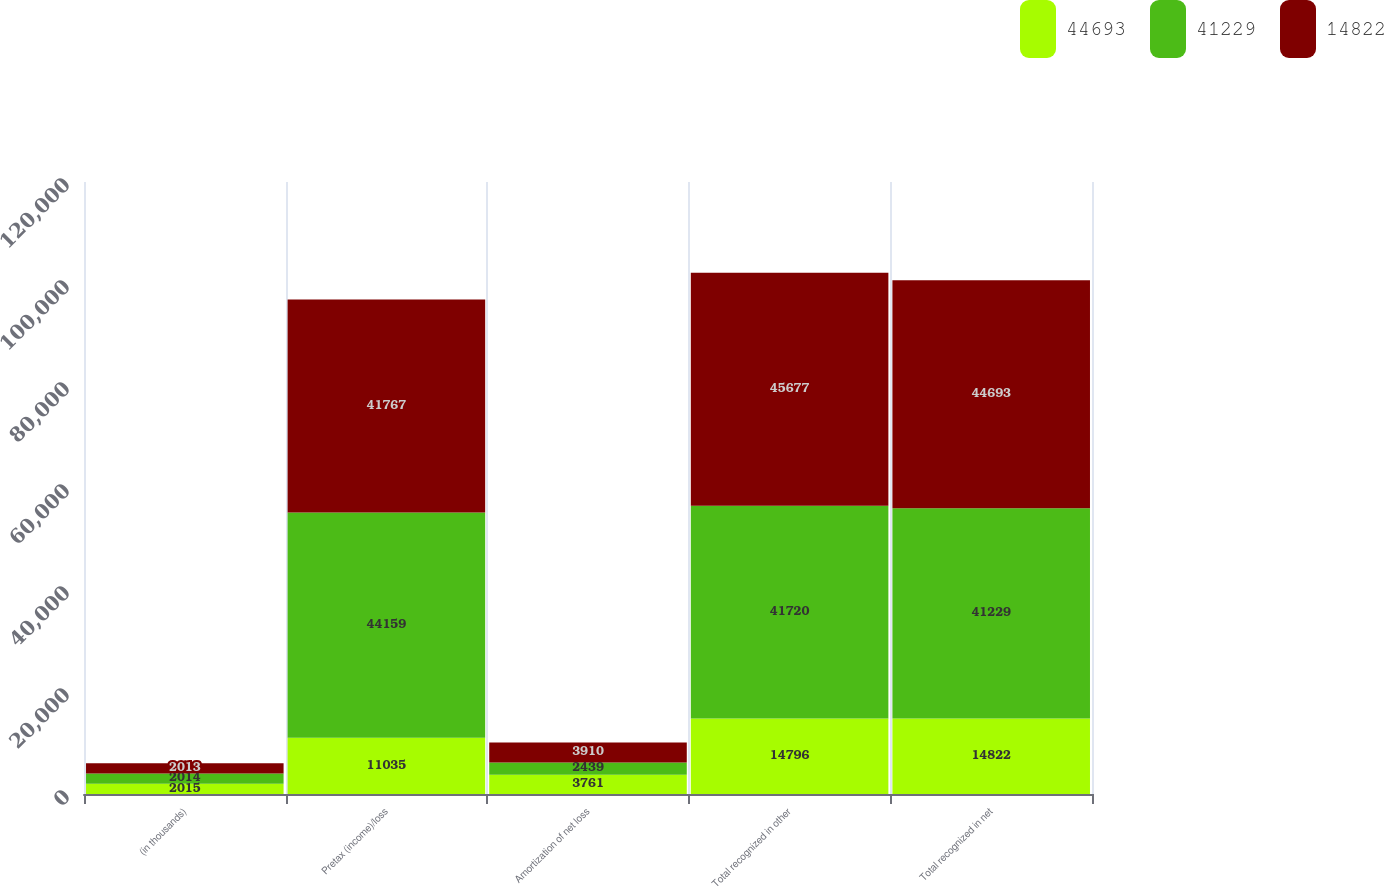<chart> <loc_0><loc_0><loc_500><loc_500><stacked_bar_chart><ecel><fcel>(in thousands)<fcel>Pretax (income)/loss<fcel>Amortization of net loss<fcel>Total recognized in other<fcel>Total recognized in net<nl><fcel>44693<fcel>2015<fcel>11035<fcel>3761<fcel>14796<fcel>14822<nl><fcel>41229<fcel>2014<fcel>44159<fcel>2439<fcel>41720<fcel>41229<nl><fcel>14822<fcel>2013<fcel>41767<fcel>3910<fcel>45677<fcel>44693<nl></chart> 